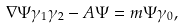<formula> <loc_0><loc_0><loc_500><loc_500>\nabla \Psi \gamma _ { 1 } \gamma _ { 2 } - A \Psi = m \Psi \gamma _ { 0 } ,</formula> 